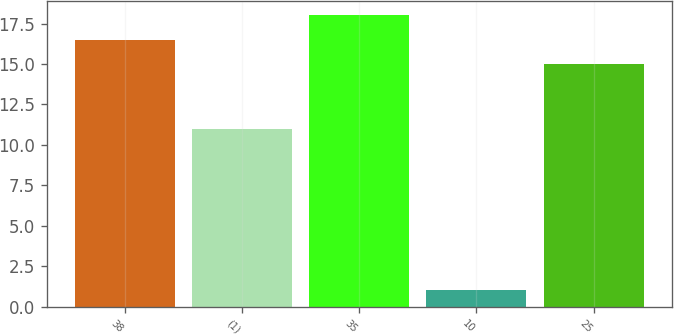<chart> <loc_0><loc_0><loc_500><loc_500><bar_chart><fcel>38<fcel>(1)<fcel>35<fcel>10<fcel>25<nl><fcel>16.5<fcel>11<fcel>18<fcel>1<fcel>15<nl></chart> 